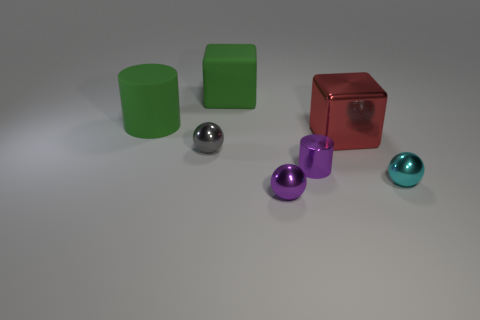Add 1 red shiny objects. How many objects exist? 8 Subtract 1 cylinders. How many cylinders are left? 1 Subtract all green cylinders. How many cylinders are left? 1 Subtract 0 cyan cubes. How many objects are left? 7 Subtract all cylinders. How many objects are left? 5 Subtract all purple cylinders. Subtract all cyan blocks. How many cylinders are left? 1 Subtract all red cylinders. How many green blocks are left? 1 Subtract all tiny shiny cylinders. Subtract all big red metallic blocks. How many objects are left? 5 Add 3 tiny gray shiny spheres. How many tiny gray shiny spheres are left? 4 Add 3 large yellow matte cylinders. How many large yellow matte cylinders exist? 3 